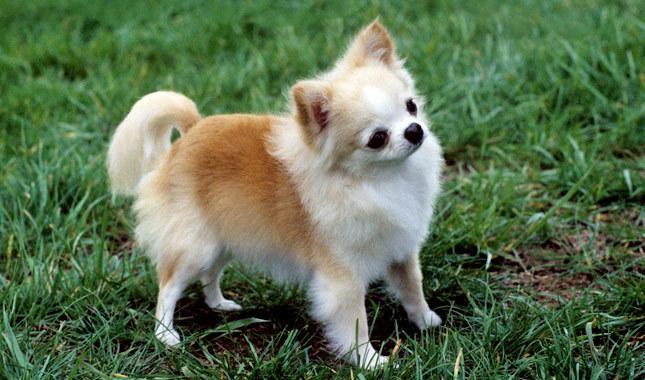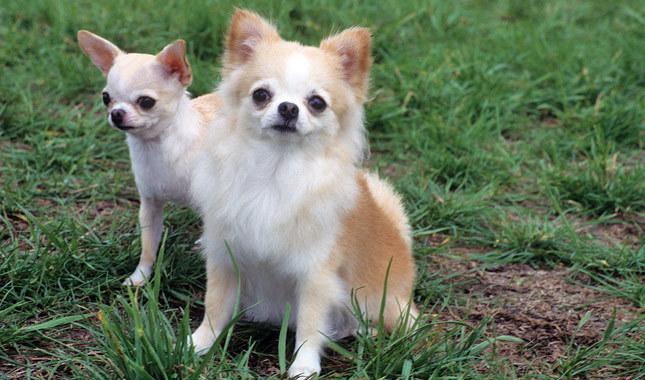The first image is the image on the left, the second image is the image on the right. Considering the images on both sides, is "At least one dog is sitting." valid? Answer yes or no. Yes. 